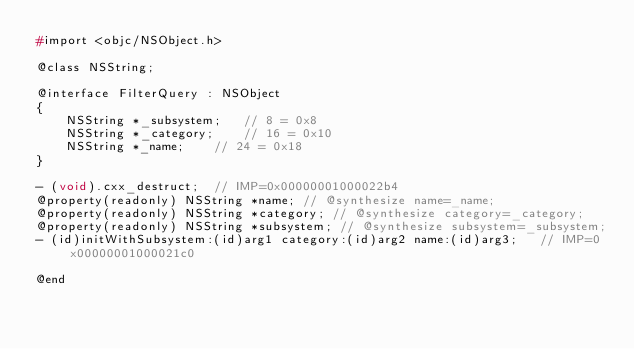Convert code to text. <code><loc_0><loc_0><loc_500><loc_500><_C_>#import <objc/NSObject.h>

@class NSString;

@interface FilterQuery : NSObject
{
    NSString *_subsystem;	// 8 = 0x8
    NSString *_category;	// 16 = 0x10
    NSString *_name;	// 24 = 0x18
}

- (void).cxx_destruct;	// IMP=0x00000001000022b4
@property(readonly) NSString *name; // @synthesize name=_name;
@property(readonly) NSString *category; // @synthesize category=_category;
@property(readonly) NSString *subsystem; // @synthesize subsystem=_subsystem;
- (id)initWithSubsystem:(id)arg1 category:(id)arg2 name:(id)arg3;	// IMP=0x00000001000021c0

@end

</code> 